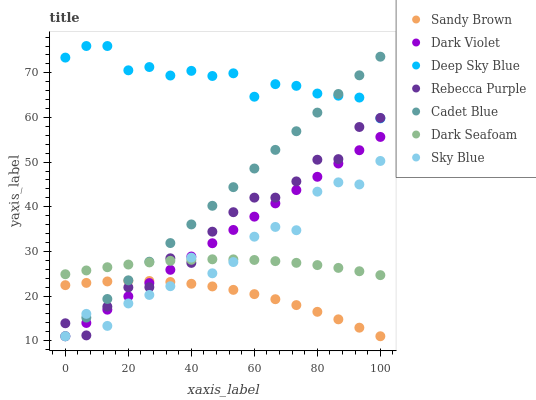Does Sandy Brown have the minimum area under the curve?
Answer yes or no. Yes. Does Deep Sky Blue have the maximum area under the curve?
Answer yes or no. Yes. Does Dark Violet have the minimum area under the curve?
Answer yes or no. No. Does Dark Violet have the maximum area under the curve?
Answer yes or no. No. Is Dark Violet the smoothest?
Answer yes or no. Yes. Is Sky Blue the roughest?
Answer yes or no. Yes. Is Dark Seafoam the smoothest?
Answer yes or no. No. Is Dark Seafoam the roughest?
Answer yes or no. No. Does Cadet Blue have the lowest value?
Answer yes or no. Yes. Does Dark Seafoam have the lowest value?
Answer yes or no. No. Does Deep Sky Blue have the highest value?
Answer yes or no. Yes. Does Dark Violet have the highest value?
Answer yes or no. No. Is Sandy Brown less than Deep Sky Blue?
Answer yes or no. Yes. Is Deep Sky Blue greater than Dark Seafoam?
Answer yes or no. Yes. Does Cadet Blue intersect Dark Violet?
Answer yes or no. Yes. Is Cadet Blue less than Dark Violet?
Answer yes or no. No. Is Cadet Blue greater than Dark Violet?
Answer yes or no. No. Does Sandy Brown intersect Deep Sky Blue?
Answer yes or no. No. 